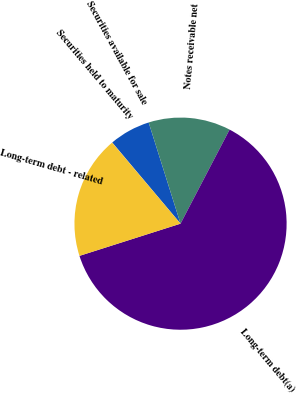Convert chart. <chart><loc_0><loc_0><loc_500><loc_500><pie_chart><fcel>Securities held to maturity<fcel>Securities available for sale<fcel>Notes receivable net<fcel>Long-term debt(a)<fcel>Long-term debt - related<nl><fcel>0.03%<fcel>6.27%<fcel>12.51%<fcel>62.43%<fcel>18.75%<nl></chart> 